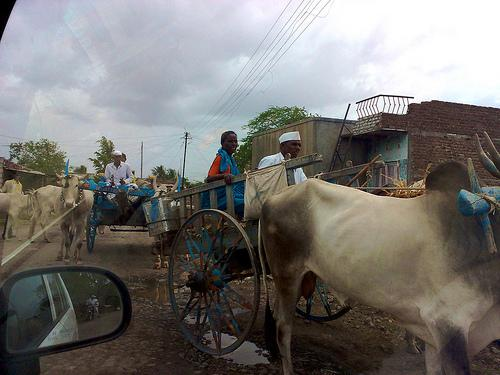What structure can be seen on top of the building? There is a balcony on top of the building. What color is the hat the man is wearing in the image? The man is wearing a white hat. What is hanging in the air above the scene? There are power lines or wires hanging in the air. What weather condition can be observed in the sky? The sky is cloudy. What is the distinguishing feature of the animal pulling the buggy? The animal has horns. Describe the appearance of the wheel on the cart. The wheel on the cart is large with rusty blue spokes. What type of wall is in the background? There is a brick wall in the background. Can you describe what the man and the woman in the image are doing? The man and the woman are sitting on a buggy being pulled by an animal. What is the surface condition of the street? The street has puddles on a dirt surface. What can be seen in the side view car mirror? A person on a bike can be seen in the side view car mirror. 